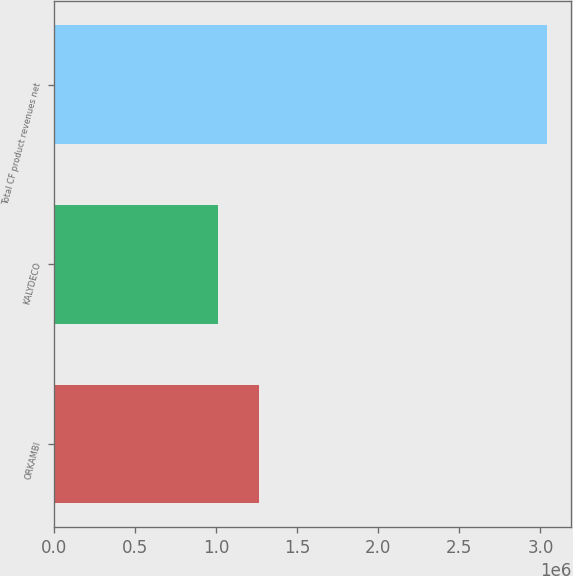Convert chart to OTSL. <chart><loc_0><loc_0><loc_500><loc_500><bar_chart><fcel>ORKAMBI<fcel>KALYDECO<fcel>Total CF product revenues net<nl><fcel>1.26217e+06<fcel>1.0075e+06<fcel>3.03832e+06<nl></chart> 